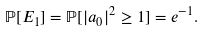<formula> <loc_0><loc_0><loc_500><loc_500>\mathbb { P } [ E _ { 1 } ] = \mathbb { P } [ | a _ { 0 } | ^ { 2 } \geq 1 ] = e ^ { - 1 } .</formula> 